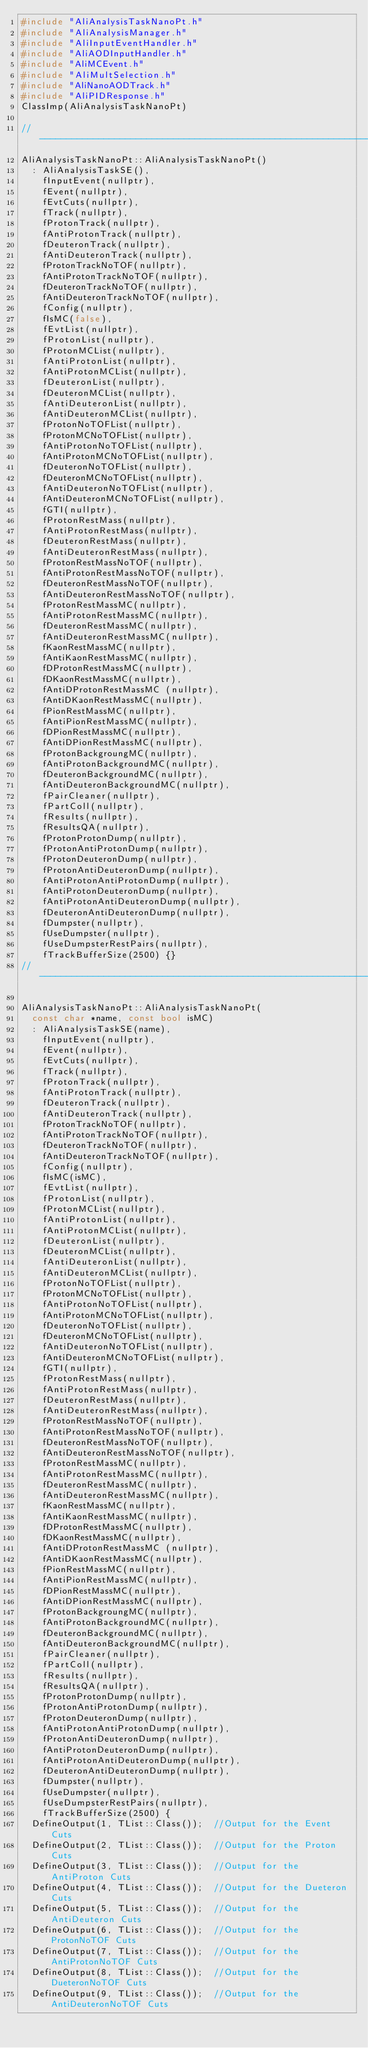Convert code to text. <code><loc_0><loc_0><loc_500><loc_500><_C++_>#include "AliAnalysisTaskNanoPt.h"
#include "AliAnalysisManager.h"
#include "AliInputEventHandler.h"
#include "AliAODInputHandler.h"
#include "AliMCEvent.h"
#include "AliMultSelection.h"
#include "AliNanoAODTrack.h"
#include "AliPIDResponse.h"
ClassImp(AliAnalysisTaskNanoPt)

//--------------------------------------------------------------------------------------------------------------------------------------------
AliAnalysisTaskNanoPt::AliAnalysisTaskNanoPt()
  : AliAnalysisTaskSE(),
    fInputEvent(nullptr),
    fEvent(nullptr),
    fEvtCuts(nullptr),
    fTrack(nullptr),
    fProtonTrack(nullptr),
    fAntiProtonTrack(nullptr),
    fDeuteronTrack(nullptr),
    fAntiDeuteronTrack(nullptr),
    fProtonTrackNoTOF(nullptr),
    fAntiProtonTrackNoTOF(nullptr),
    fDeuteronTrackNoTOF(nullptr),
    fAntiDeuteronTrackNoTOF(nullptr),
    fConfig(nullptr),
    fIsMC(false),
    fEvtList(nullptr),
    fProtonList(nullptr),
    fProtonMCList(nullptr),
    fAntiProtonList(nullptr),
    fAntiProtonMCList(nullptr),
    fDeuteronList(nullptr),
    fDeuteronMCList(nullptr),
    fAntiDeuteronList(nullptr),
    fAntiDeuteronMCList(nullptr),
    fProtonNoTOFList(nullptr),
    fProtonMCNoTOFList(nullptr),
    fAntiProtonNoTOFList(nullptr),
    fAntiProtonMCNoTOFList(nullptr),
    fDeuteronNoTOFList(nullptr),
    fDeuteronMCNoTOFList(nullptr),
    fAntiDeuteronNoTOFList(nullptr),
    fAntiDeuteronMCNoTOFList(nullptr),
    fGTI(nullptr),
    fProtonRestMass(nullptr),
    fAntiProtonRestMass(nullptr),
    fDeuteronRestMass(nullptr),
    fAntiDeuteronRestMass(nullptr),
    fProtonRestMassNoTOF(nullptr),
    fAntiProtonRestMassNoTOF(nullptr),
    fDeuteronRestMassNoTOF(nullptr),
    fAntiDeuteronRestMassNoTOF(nullptr),
    fProtonRestMassMC(nullptr),
    fAntiProtonRestMassMC(nullptr),
    fDeuteronRestMassMC(nullptr),
    fAntiDeuteronRestMassMC(nullptr),
    fKaonRestMassMC(nullptr),
    fAntiKaonRestMassMC(nullptr),
    fDProtonRestMassMC(nullptr),
    fDKaonRestMassMC(nullptr),
    fAntiDProtonRestMassMC (nullptr),
    fAntiDKaonRestMassMC(nullptr),
    fPionRestMassMC(nullptr),
    fAntiPionRestMassMC(nullptr),
    fDPionRestMassMC(nullptr),
    fAntiDPionRestMassMC(nullptr),
    fProtonBackgroungMC(nullptr),
    fAntiProtonBackgroundMC(nullptr),
    fDeuteronBackgroundMC(nullptr),
    fAntiDeuteronBackgroundMC(nullptr),
    fPairCleaner(nullptr),
    fPartColl(nullptr),
    fResults(nullptr),
    fResultsQA(nullptr),
    fProtonProtonDump(nullptr),
    fProtonAntiProtonDump(nullptr),
    fProtonDeuteronDump(nullptr),
    fProtonAntiDeuteronDump(nullptr),
    fAntiProtonAntiProtonDump(nullptr),
    fAntiProtonDeuteronDump(nullptr),
    fAntiProtonAntiDeuteronDump(nullptr),
    fDeuteronAntiDeuteronDump(nullptr),
    fDumpster(nullptr),
    fUseDumpster(nullptr),
    fUseDumpsterRestPairs(nullptr),
    fTrackBufferSize(2500) {}
//-----------------------------------------------------------------------------------------------------------------------

AliAnalysisTaskNanoPt::AliAnalysisTaskNanoPt(
  const char *name, const bool isMC)
  : AliAnalysisTaskSE(name),
    fInputEvent(nullptr),
    fEvent(nullptr),
    fEvtCuts(nullptr),
    fTrack(nullptr),
    fProtonTrack(nullptr),
    fAntiProtonTrack(nullptr),
    fDeuteronTrack(nullptr),
    fAntiDeuteronTrack(nullptr),
    fProtonTrackNoTOF(nullptr),
    fAntiProtonTrackNoTOF(nullptr),
    fDeuteronTrackNoTOF(nullptr),
    fAntiDeuteronTrackNoTOF(nullptr),
    fConfig(nullptr),
    fIsMC(isMC),
    fEvtList(nullptr),
    fProtonList(nullptr),
    fProtonMCList(nullptr),
    fAntiProtonList(nullptr),
    fAntiProtonMCList(nullptr),
    fDeuteronList(nullptr),
    fDeuteronMCList(nullptr),
    fAntiDeuteronList(nullptr),
    fAntiDeuteronMCList(nullptr),
    fProtonNoTOFList(nullptr),
    fProtonMCNoTOFList(nullptr),
    fAntiProtonNoTOFList(nullptr),
    fAntiProtonMCNoTOFList(nullptr),
    fDeuteronNoTOFList(nullptr),
    fDeuteronMCNoTOFList(nullptr),
    fAntiDeuteronNoTOFList(nullptr),
    fAntiDeuteronMCNoTOFList(nullptr),
    fGTI(nullptr),
    fProtonRestMass(nullptr),
    fAntiProtonRestMass(nullptr),
    fDeuteronRestMass(nullptr),
    fAntiDeuteronRestMass(nullptr),
    fProtonRestMassNoTOF(nullptr),
    fAntiProtonRestMassNoTOF(nullptr),
    fDeuteronRestMassNoTOF(nullptr),
    fAntiDeuteronRestMassNoTOF(nullptr),
    fProtonRestMassMC(nullptr),
    fAntiProtonRestMassMC(nullptr),
    fDeuteronRestMassMC(nullptr),
    fAntiDeuteronRestMassMC(nullptr),
    fKaonRestMassMC(nullptr),
    fAntiKaonRestMassMC(nullptr),
    fDProtonRestMassMC(nullptr),
    fDKaonRestMassMC(nullptr),
    fAntiDProtonRestMassMC (nullptr),
    fAntiDKaonRestMassMC(nullptr),
    fPionRestMassMC(nullptr),
    fAntiPionRestMassMC(nullptr),
    fDPionRestMassMC(nullptr),
    fAntiDPionRestMassMC(nullptr),
    fProtonBackgroungMC(nullptr),
    fAntiProtonBackgroundMC(nullptr),
    fDeuteronBackgroundMC(nullptr),
    fAntiDeuteronBackgroundMC(nullptr),
    fPairCleaner(nullptr),
    fPartColl(nullptr),
    fResults(nullptr),
    fResultsQA(nullptr),
    fProtonProtonDump(nullptr),
    fProtonAntiProtonDump(nullptr),
    fProtonDeuteronDump(nullptr),
    fAntiProtonAntiProtonDump(nullptr),
    fProtonAntiDeuteronDump(nullptr),
    fAntiProtonDeuteronDump(nullptr),
    fAntiProtonAntiDeuteronDump(nullptr),
    fDeuteronAntiDeuteronDump(nullptr),
    fDumpster(nullptr),
    fUseDumpster(nullptr),
    fUseDumpsterRestPairs(nullptr),
    fTrackBufferSize(2500) {
  DefineOutput(1, TList::Class());  //Output for the Event Cuts
  DefineOutput(2, TList::Class());  //Output for the Proton Cuts
  DefineOutput(3, TList::Class());  //Output for the AntiProton Cuts
  DefineOutput(4, TList::Class());  //Output for the Dueteron Cuts
  DefineOutput(5, TList::Class());  //Output for the AntiDeuteron Cuts
  DefineOutput(6, TList::Class());  //Output for the ProtonNoTOF Cuts
  DefineOutput(7, TList::Class());  //Output for the AntiProtonNoTOF Cuts
  DefineOutput(8, TList::Class());  //Output for the DueteronNoTOF Cuts
  DefineOutput(9, TList::Class());  //Output for the AntiDeuteronNoTOF Cuts</code> 